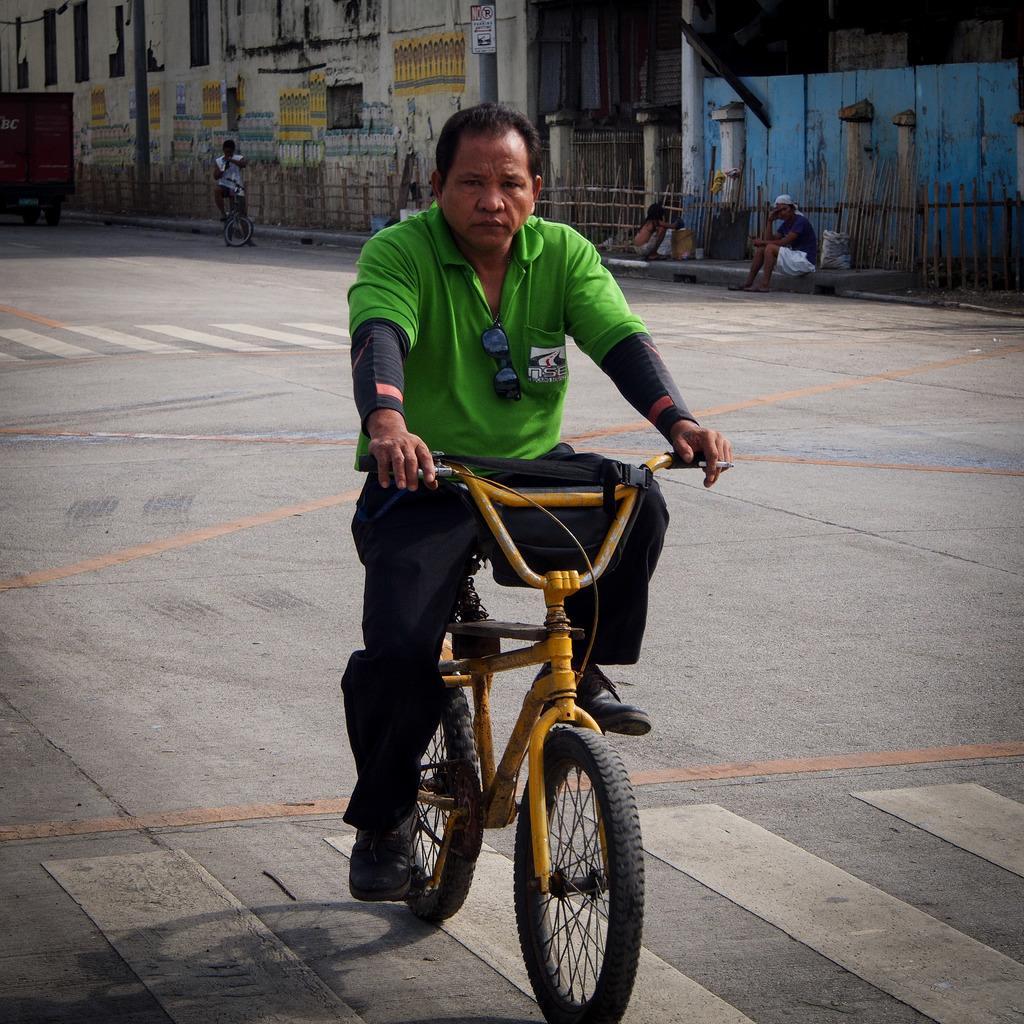Could you give a brief overview of what you see in this image? In this image we can see four person on the road. In front the man is riding a bicycle on the road. At the background we can see a building and vehicle,On the right side we can man is sitting on the footpath and we can see a fencing on the right side. 